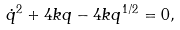<formula> <loc_0><loc_0><loc_500><loc_500>\dot { q } ^ { 2 } + 4 k q - 4 k q ^ { 1 / 2 } = 0 ,</formula> 